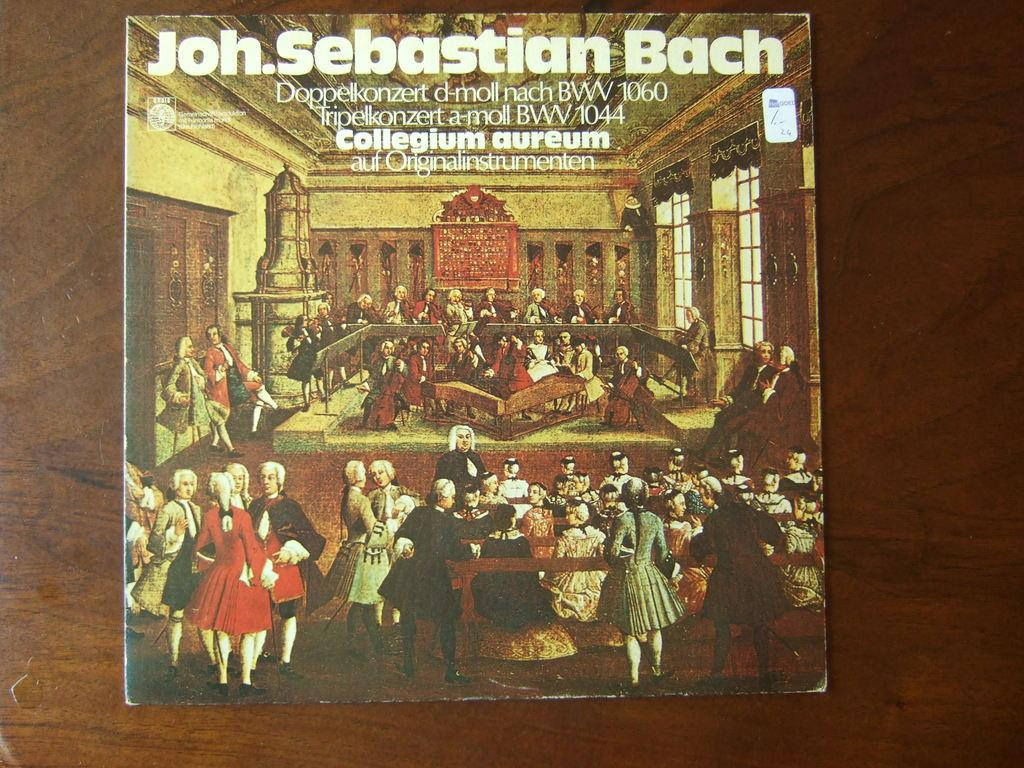What type of information can be seen in the image? There is text and numbers visible in the image. What are the people in the image doing? There are people sitting on benches in the image. What is the board with other objects located on? The board is visible on a wooden wall in the image. What invention is being demonstrated on the board in the image? There is no invention being demonstrated on the board in the image; it contains text and numbers, as well as other objects. Can you tell me how many rocks are visible on the board in the image? There are no rocks visible on the board in the image. 